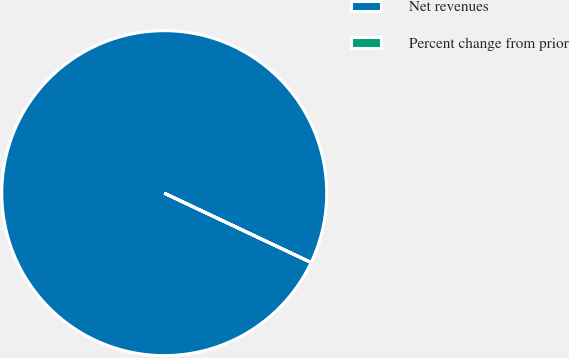Convert chart. <chart><loc_0><loc_0><loc_500><loc_500><pie_chart><fcel>Net revenues<fcel>Percent change from prior<nl><fcel>100.0%<fcel>0.0%<nl></chart> 